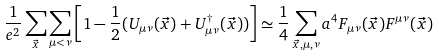Convert formula to latex. <formula><loc_0><loc_0><loc_500><loc_500>\frac { 1 } { e ^ { 2 } } \sum _ { \vec { x } } \sum _ { \mu < \nu } \left [ 1 - \frac { 1 } { 2 } ( U _ { \mu \nu } ( \vec { x } ) + U _ { \mu \nu } ^ { \dagger } ( \vec { x } ) ) \right ] \simeq \frac { 1 } { 4 } \sum _ { \vec { x } , \mu , \nu } a ^ { 4 } F _ { \mu \nu } ( \vec { x } ) F ^ { \mu \nu } ( \vec { x } )</formula> 